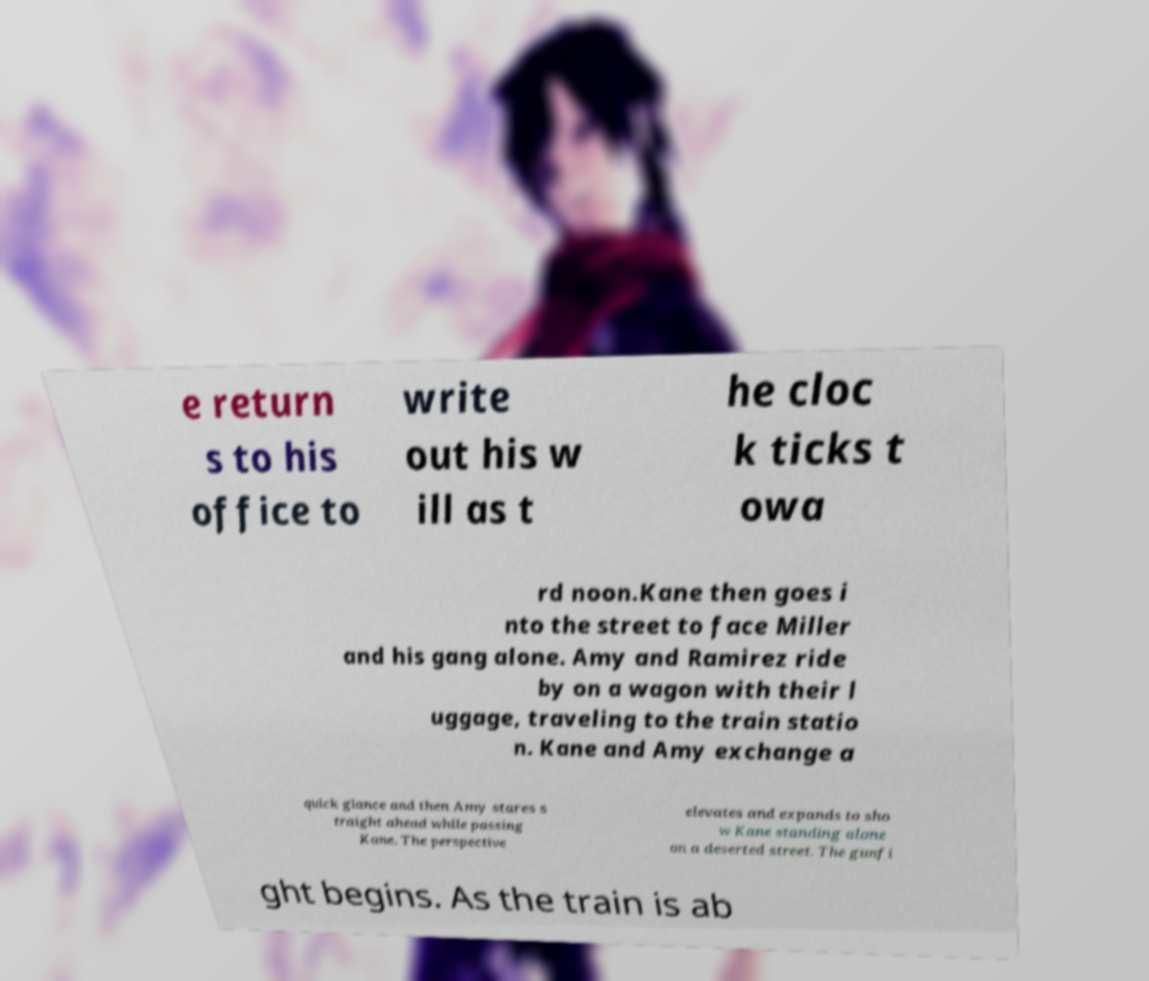Can you accurately transcribe the text from the provided image for me? e return s to his office to write out his w ill as t he cloc k ticks t owa rd noon.Kane then goes i nto the street to face Miller and his gang alone. Amy and Ramirez ride by on a wagon with their l uggage, traveling to the train statio n. Kane and Amy exchange a quick glance and then Amy stares s traight ahead while passing Kane. The perspective elevates and expands to sho w Kane standing alone on a deserted street. The gunfi ght begins. As the train is ab 